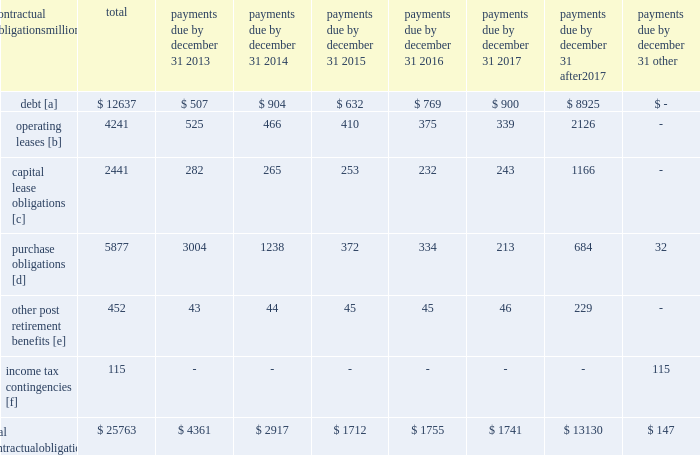Credit rating fall below investment grade , the value of the outstanding undivided interest held by investors would be reduced , and , in certain cases , the investors would have the right to discontinue the facility .
The railroad collected approximately $ 20.1 billion and $ 18.8 billion of receivables during the years ended december 31 , 2012 and 2011 , respectively .
Upri used certain of these proceeds to purchase new receivables under the facility .
The costs of the receivables securitization facility include interest , which will vary based on prevailing commercial paper rates , program fees paid to banks , commercial paper issuing costs , and fees for unused commitment availability .
The costs of the receivables securitization facility are included in interest expense and were $ 3 million , $ 4 million and $ 6 million for 2012 , 2011 and 2010 , respectively .
The investors have no recourse to the railroad 2019s other assets , except for customary warranty and indemnity claims .
Creditors of the railroad do not have recourse to the assets of upri .
In july 2012 , the receivables securitization facility was renewed for an additional 364-day period at comparable terms and conditions .
Subsequent event 2013 on january 2 , 2013 , we transferred an additional $ 300 million in undivided interest to investors under the receivables securitization facility , increasing the value of the outstanding undivided interest held by investors from $ 100 million to $ 400 million .
Contractual obligations and commercial commitments as described in the notes to the consolidated financial statements and as referenced in the tables below , we have contractual obligations and commercial commitments that may affect our financial condition .
Based on our assessment of the underlying provisions and circumstances of our contractual obligations and commercial commitments , including material sources of off-balance sheet and structured finance arrangements , other than the risks that we and other similarly situated companies face with respect to the condition of the capital markets ( as described in item 1a of part ii of this report ) , there is no known trend , demand , commitment , event , or uncertainty that is reasonably likely to occur that would have a material adverse effect on our consolidated results of operations , financial condition , or liquidity .
In addition , our commercial obligations , financings , and commitments are customary transactions that are similar to those of other comparable corporations , particularly within the transportation industry .
The tables identify material obligations and commitments as of december 31 , 2012 : payments due by december 31 , contractual obligations after millions total 2013 2014 2015 2016 2017 2017 other .
[a] excludes capital lease obligations of $ 1848 million and unamortized discount of $ ( 365 ) million .
Includes an interest component of $ 5123 million .
[b] includes leases for locomotives , freight cars , other equipment , and real estate .
[c] represents total obligations , including interest component of $ 593 million .
[d] purchase obligations include locomotive maintenance contracts ; purchase commitments for fuel purchases , locomotives , ties , ballast , and rail ; and agreements to purchase other goods and services .
For amounts where we cannot reasonably estimate the year of settlement , they are reflected in the other column .
[e] includes estimated other post retirement , medical , and life insurance payments , payments made under the unfunded pension plan for the next ten years .
[f] future cash flows for income tax contingencies reflect the recorded liabilities and assets for unrecognized tax benefits , including interest and penalties , as of december 31 , 2012 .
For amounts where the year of settlement is uncertain , they are reflected in the other column. .
What percentage of total material obligations and commitments as of december 31 , 2012 are capital leases obligations? 
Computations: (2441 / 25763)
Answer: 0.09475. 